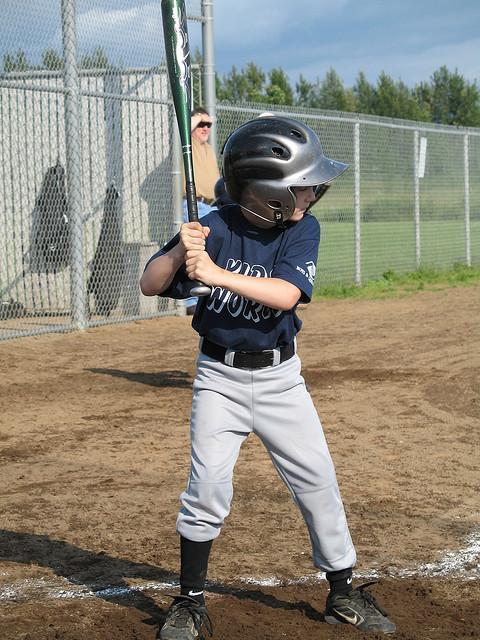How many people are there?
Give a very brief answer. 2. 